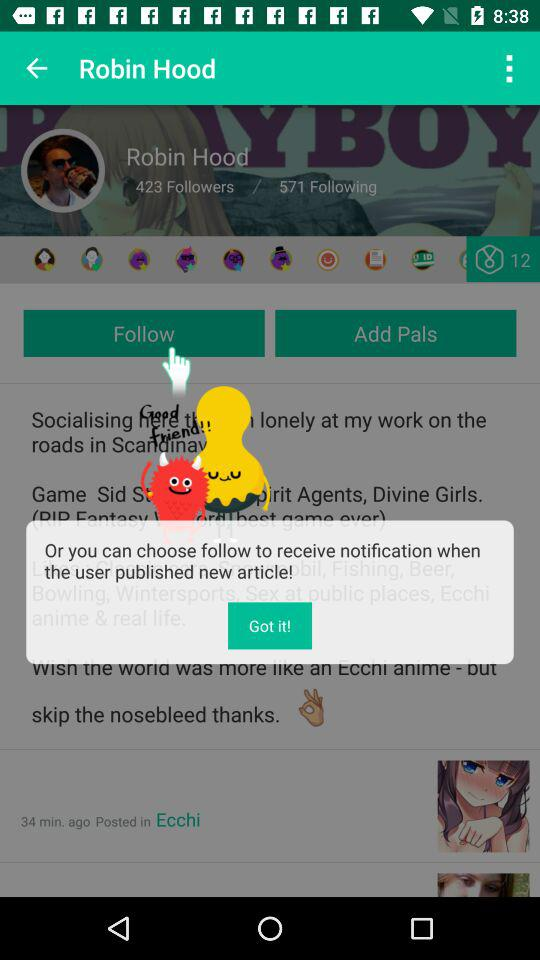What is the name of the profile person? The name of the profile person is Robin Hood. 